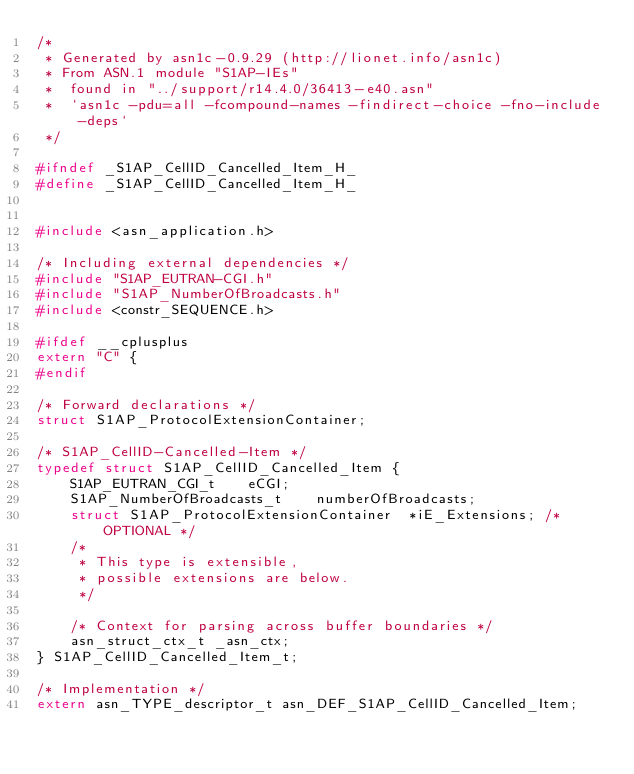<code> <loc_0><loc_0><loc_500><loc_500><_C_>/*
 * Generated by asn1c-0.9.29 (http://lionet.info/asn1c)
 * From ASN.1 module "S1AP-IEs"
 * 	found in "../support/r14.4.0/36413-e40.asn"
 * 	`asn1c -pdu=all -fcompound-names -findirect-choice -fno-include-deps`
 */

#ifndef	_S1AP_CellID_Cancelled_Item_H_
#define	_S1AP_CellID_Cancelled_Item_H_


#include <asn_application.h>

/* Including external dependencies */
#include "S1AP_EUTRAN-CGI.h"
#include "S1AP_NumberOfBroadcasts.h"
#include <constr_SEQUENCE.h>

#ifdef __cplusplus
extern "C" {
#endif

/* Forward declarations */
struct S1AP_ProtocolExtensionContainer;

/* S1AP_CellID-Cancelled-Item */
typedef struct S1AP_CellID_Cancelled_Item {
	S1AP_EUTRAN_CGI_t	 eCGI;
	S1AP_NumberOfBroadcasts_t	 numberOfBroadcasts;
	struct S1AP_ProtocolExtensionContainer	*iE_Extensions;	/* OPTIONAL */
	/*
	 * This type is extensible,
	 * possible extensions are below.
	 */
	
	/* Context for parsing across buffer boundaries */
	asn_struct_ctx_t _asn_ctx;
} S1AP_CellID_Cancelled_Item_t;

/* Implementation */
extern asn_TYPE_descriptor_t asn_DEF_S1AP_CellID_Cancelled_Item;</code> 